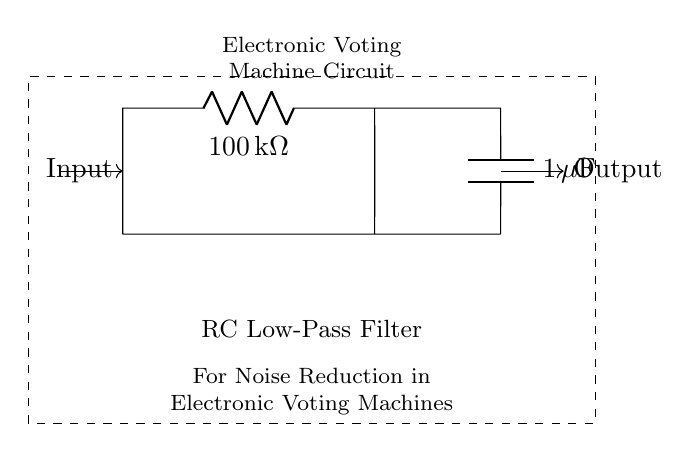What type of filter does this circuit represent? This circuit is an RC Low-Pass Filter, which allows low-frequency signals to pass while attenuating higher frequency signals.
Answer: RC Low-Pass Filter What is the resistance value in the circuit? The resistance is indicated next to the resistor symbol as one hundred k ohms.
Answer: 100 k ohms What is the capacitance value in the circuit? The capacitance is indicated next to the capacitor symbol as one microfarad.
Answer: 1 microfarad What is the main purpose of this RC filter in voting machines? The main purpose is noise reduction, ensuring that only stable signals are transmitted and processed.
Answer: Noise reduction How does the time constant of this RC circuit affect its performance? The time constant, which is the product of resistance and capacitance, determines how quickly the circuit responds to changes in input voltage. A larger time constant results in slower response.
Answer: Slower response What happens to high-frequency signals in this RC low-pass filter? High-frequency signals are attenuated, meaning they are reduced in amplitude as they pass through the filter, which helps eliminate noise.
Answer: Attenuated What is the output of this circuit when a rapid voltage change occurs at the input? The output will lag behind the input because the RC circuit cannot react instantaneously to rapid changes, filtering them out over time.
Answer: Lags behind input 